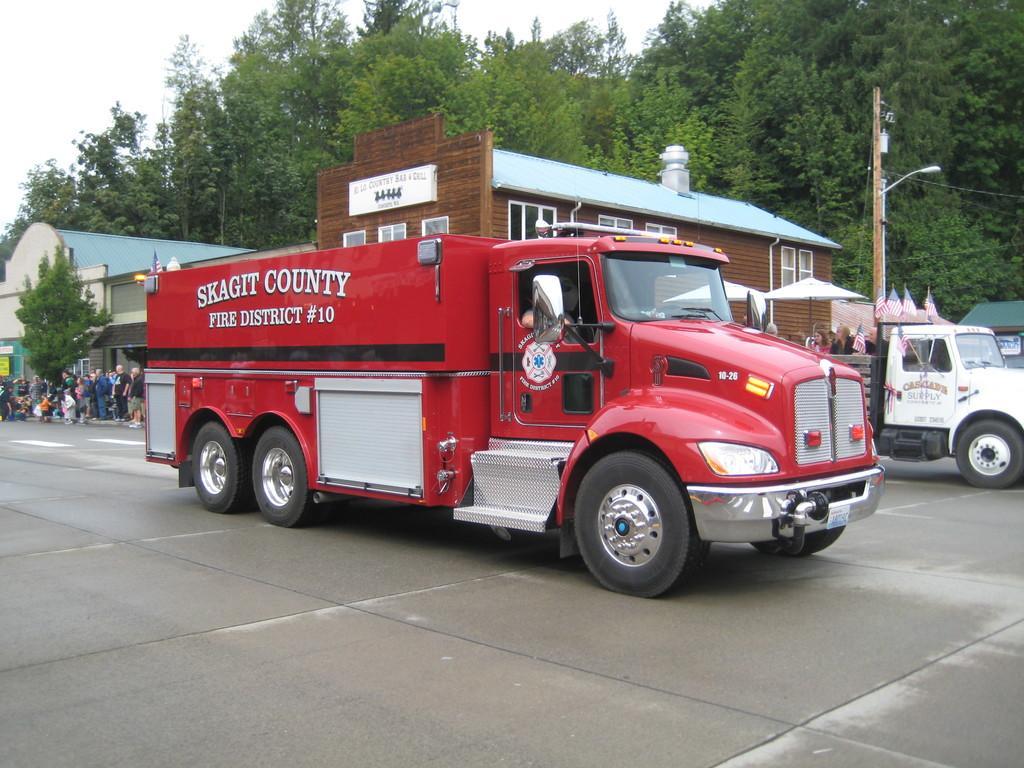In one or two sentences, can you explain what this image depicts? In the middle of the image there are some vehicles on the road. Behind the vehicles there are some buildings and poles and trees and few people are standing. At the top of the image there are some clouds and sky. 